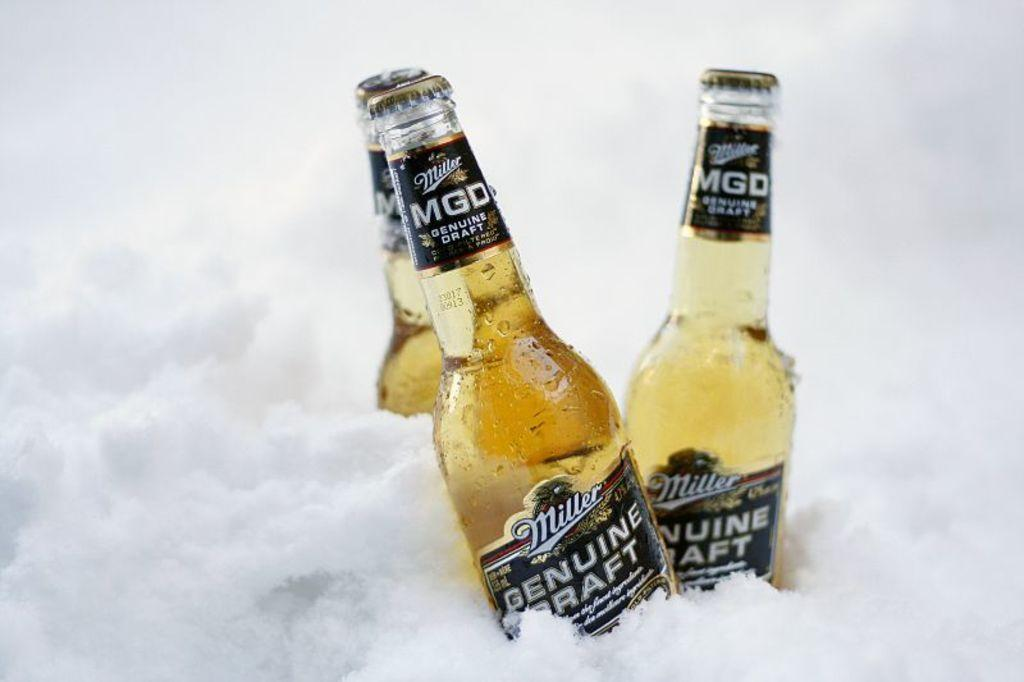<image>
Share a concise interpretation of the image provided. Two bottles of Miller Genuine Draft inside some crushed ice. 